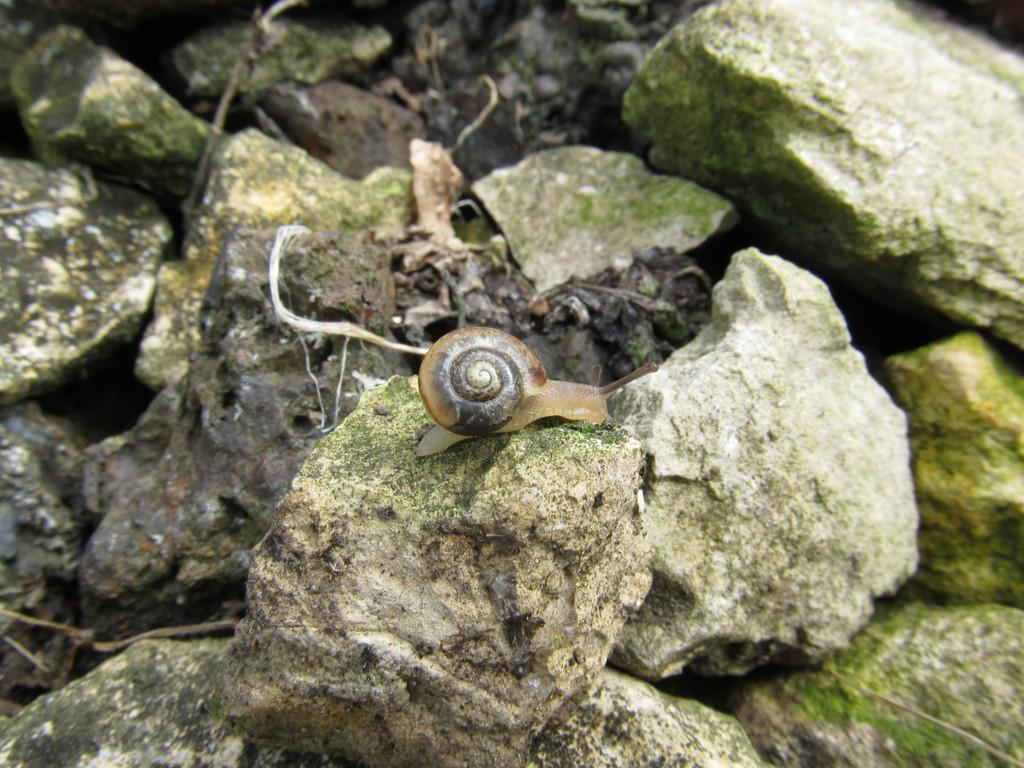What type of animal can be seen on the ground in the image? There is a snail on the ground in the image. What else is present on the ground in the image? There are stones on the ground in the image. What type of houses can be seen in the background of the image? There are no houses visible in the image; it only features a snail and stones on the ground. What scene is being protested in the image? There is no protest or scene being depicted in the image; it only features a snail and stones on the ground. 